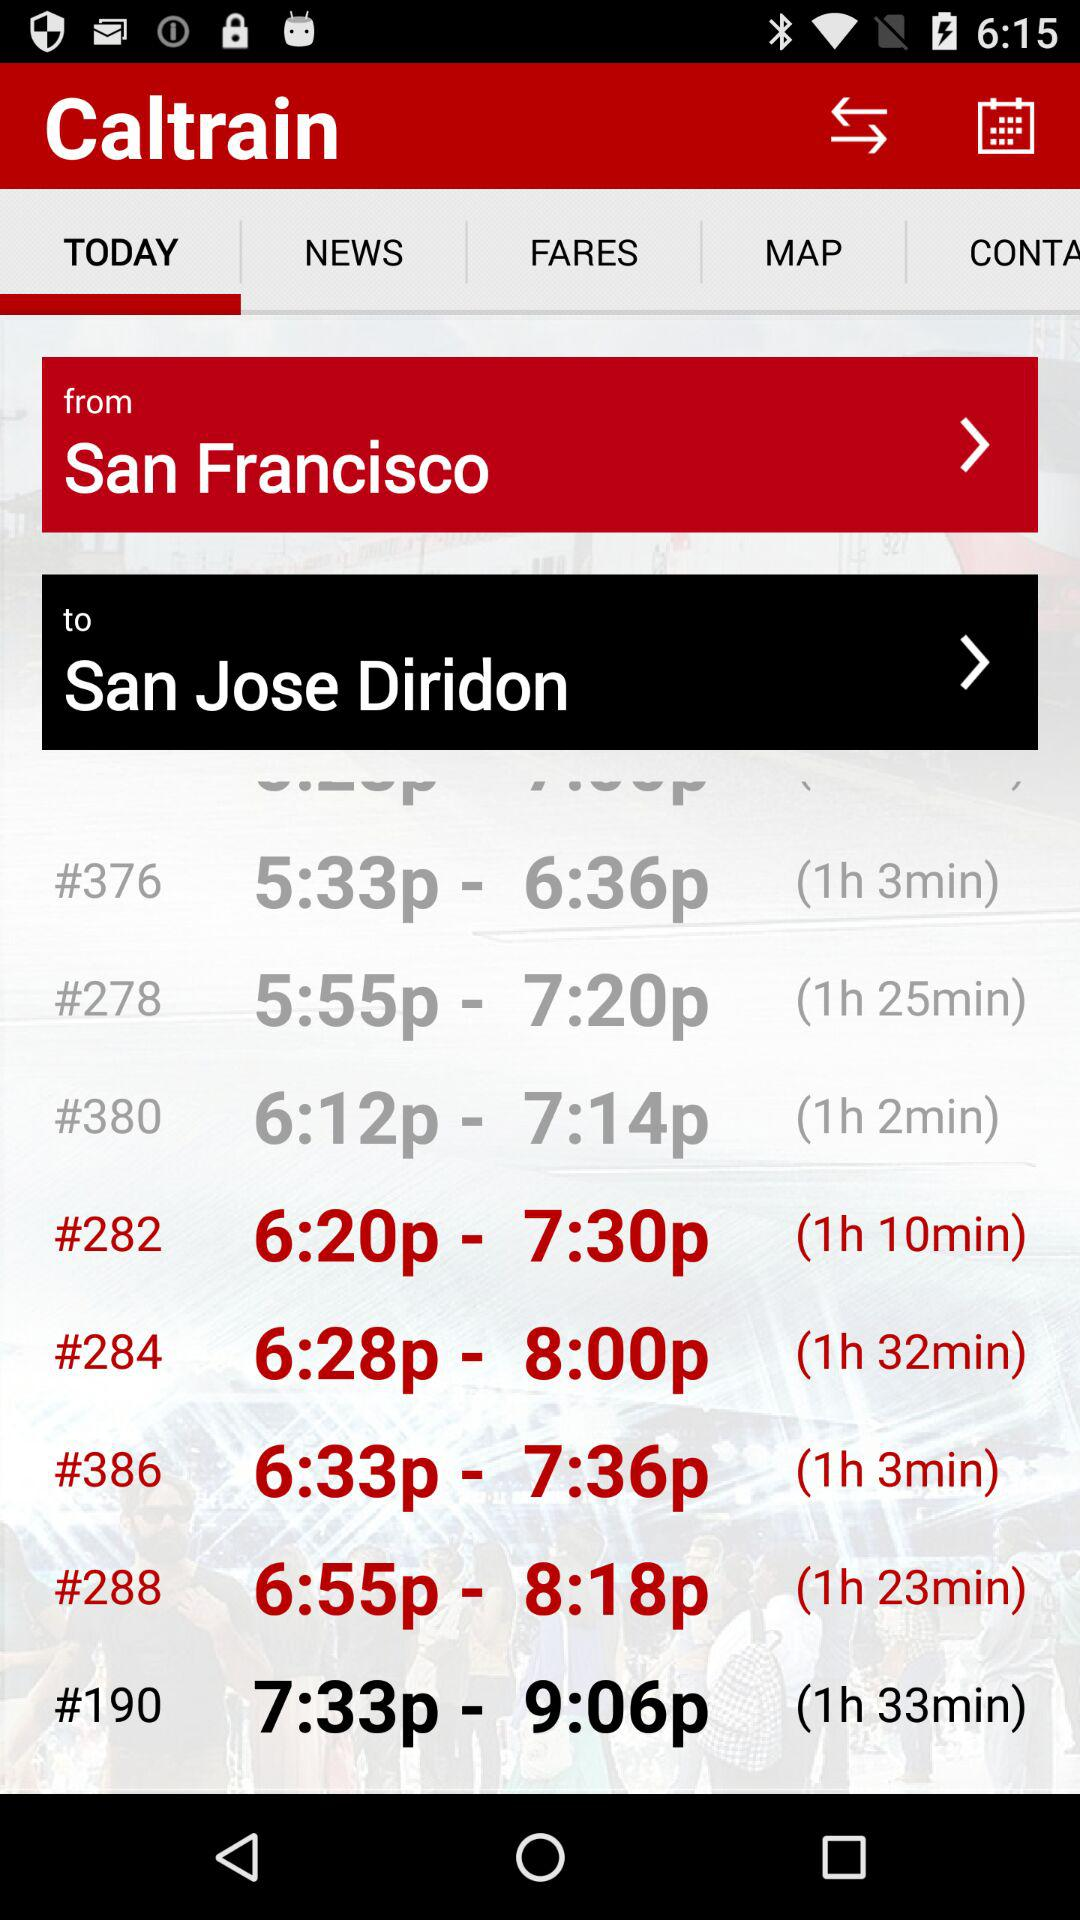How much time does the train with the number 288 take? The train with the number 288 takes 1 hour and 23 minutes. 